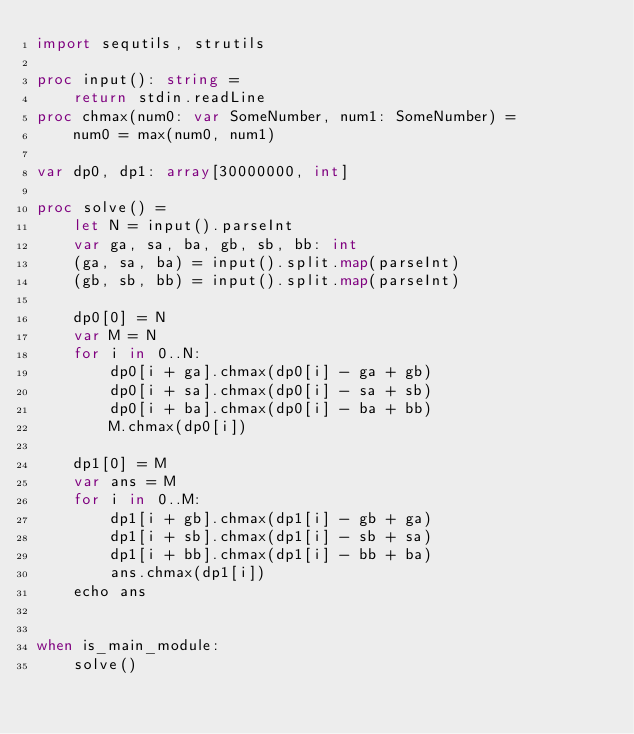<code> <loc_0><loc_0><loc_500><loc_500><_Nim_>import sequtils, strutils

proc input(): string =
    return stdin.readLine
proc chmax(num0: var SomeNumber, num1: SomeNumber) =
    num0 = max(num0, num1)

var dp0, dp1: array[30000000, int]

proc solve() =
    let N = input().parseInt
    var ga, sa, ba, gb, sb, bb: int
    (ga, sa, ba) = input().split.map(parseInt)
    (gb, sb, bb) = input().split.map(parseInt)

    dp0[0] = N
    var M = N
    for i in 0..N:
        dp0[i + ga].chmax(dp0[i] - ga + gb)
        dp0[i + sa].chmax(dp0[i] - sa + sb)
        dp0[i + ba].chmax(dp0[i] - ba + bb)
        M.chmax(dp0[i])
    
    dp1[0] = M
    var ans = M
    for i in 0..M:
        dp1[i + gb].chmax(dp1[i] - gb + ga)
        dp1[i + sb].chmax(dp1[i] - sb + sa)
        dp1[i + bb].chmax(dp1[i] - bb + ba)
        ans.chmax(dp1[i])
    echo ans


when is_main_module:
    solve()
</code> 